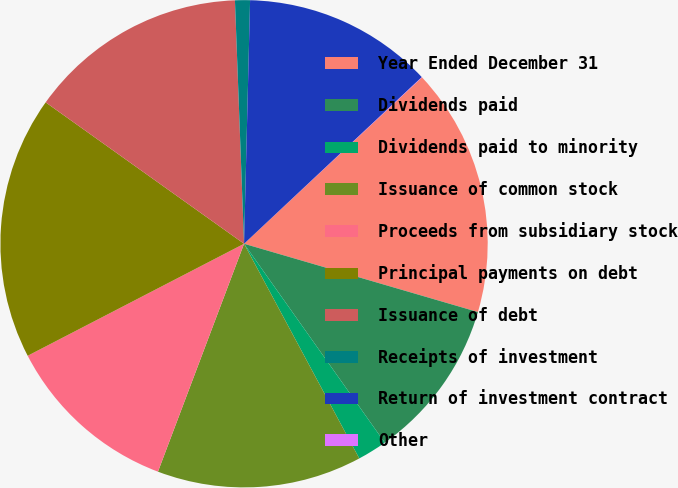Convert chart. <chart><loc_0><loc_0><loc_500><loc_500><pie_chart><fcel>Year Ended December 31<fcel>Dividends paid<fcel>Dividends paid to minority<fcel>Issuance of common stock<fcel>Proceeds from subsidiary stock<fcel>Principal payments on debt<fcel>Issuance of debt<fcel>Receipts of investment<fcel>Return of investment contract<fcel>Other<nl><fcel>16.49%<fcel>10.68%<fcel>1.96%<fcel>13.59%<fcel>11.65%<fcel>17.46%<fcel>14.55%<fcel>0.99%<fcel>12.62%<fcel>0.02%<nl></chart> 